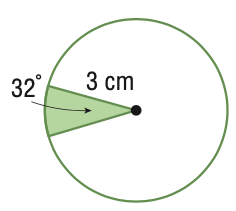Answer the mathemtical geometry problem and directly provide the correct option letter.
Question: Find the area of the sector. Round to the nearest tenth.
Choices: A: 1.7 B: 2.5 C: 25.8 D: 28.3 B 